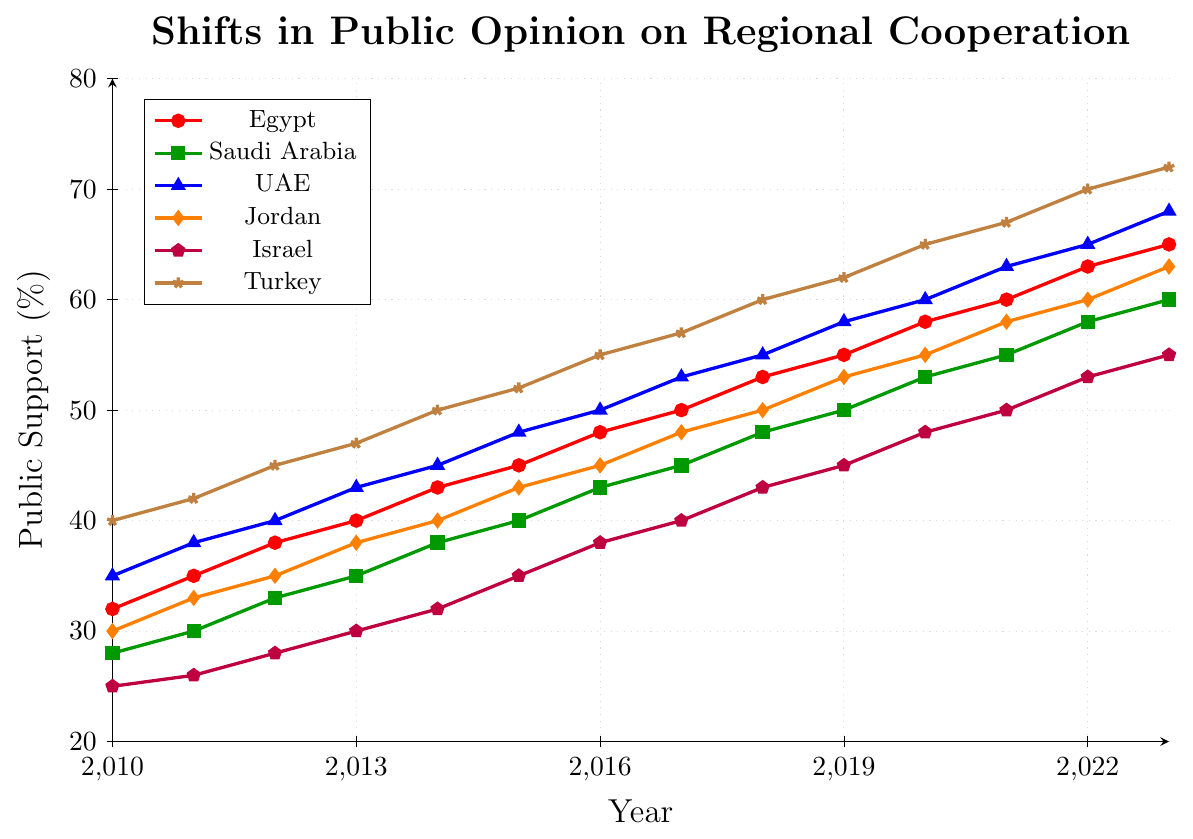What's the overall trend in public support for regional cooperation in all the countries from 2010 to 2023? We observe that the public support for regional cooperation in all countries (Egypt, Saudi Arabia, UAE, Jordan, Israel, Turkey) shows an increasing trend from 2010 to 2023 as indicated by the upward slope of all the colored lines.
Answer: Increasing Which country had the highest public support for regional cooperation in 2010 and which had the lowest? In 2010, Turkey had the highest public support at 40%, while Israel had the lowest at 25%. This can be observed by comparing the starting points of the lines on the y-axis for each country.
Answer: Turkey 40%, Israel 25% How does the growth rate of public support in Saudi Arabia compare to that in Jordan from 2010 to 2023? Saudi Arabia's support grew from 28% to 60%, and Jordan's grew from 30% to 63%. The increase for Saudi Arabia is 60 - 28 = 32% and for Jordan is 63 - 30 = 33%. Therefore, the growth rates are nearly identical, with Jordan having a slightly higher increase by 1%.
Answer: Jordan has a slightly higher growth rate by 1% In which year did Egypt surpass 50% public support for regional cooperation? The line for Egypt crosses the 50% mark between the years 2017 and 2018, and it is at 53% in 2018. Hence, Egypt surpasses the 50% mark in 2018.
Answer: 2018 Which country had the smallest increase in public support from 2010 to 2023? Comparing the increases: Egypt (65 - 32 = 33%), Saudi Arabia (60 - 28 = 32%), UAE (68 - 35 = 33%), Jordan (63 - 30 = 33%), Israel (55 - 25 = 30%), Turkey (72 - 40 = 32%). Israel had the smallest increase, which is 30%.
Answer: Israel Between which two consecutive years did Turkey see the greatest increase in public support? The greatest increase in Turkey's line is observed between 2016 and 2017, where it increases from 55% to 57%, a rise of 2%. By calculating the yearly differences, this is the largest increase observed.
Answer: 2016-2017 Compare the public support percentages of UAE and Israel in 2023. How much higher is UAE's support? In 2023, UAE has a public support of 68%, whereas Israel has 55%. The difference is 68% - 55% = 13%. Therefore, UAE's support is 13% higher than Israel's.
Answer: 13% higher What is the average public support for regional cooperation in Egypt across all the recorded years? The support values for Egypt are {32, 35, 38, 40, 43, 45, 48, 50, 53, 55, 58, 60, 63, 65}, summing these values: 695. The average is 695/14 = 49.64% (rounded to two decimal places).
Answer: 49.64% Is there any year where the public support was the same for two or more countries? No, by visually inspecting the plot, no two countries' lines are at the same y-axis value for any given year; all support percentages are distinct.
Answer: No Which country had the most stable increase in public support over the years, judging by the smoothness and slope of its line? Judging by the smoothness and consistent upward slope of the lines, Saudi Arabia appears to have the most stable and consistent increase in public support.
Answer: Saudi Arabia 